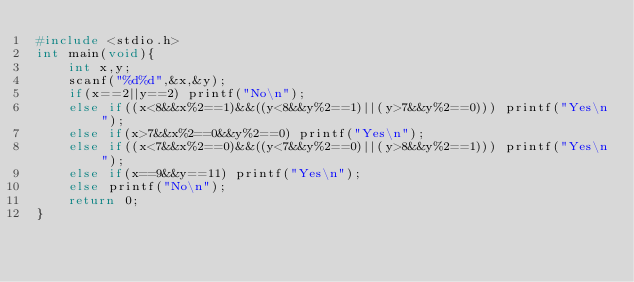Convert code to text. <code><loc_0><loc_0><loc_500><loc_500><_C_>#include <stdio.h>
int main(void){
    int x,y;
    scanf("%d%d",&x,&y);
    if(x==2||y==2) printf("No\n");
    else if((x<8&&x%2==1)&&((y<8&&y%2==1)||(y>7&&y%2==0))) printf("Yes\n");
    else if(x>7&&x%2==0&&y%2==0) printf("Yes\n");
    else if((x<7&&x%2==0)&&((y<7&&y%2==0)||(y>8&&y%2==1))) printf("Yes\n");
    else if(x==9&&y==11) printf("Yes\n");
    else printf("No\n");
    return 0;
}</code> 